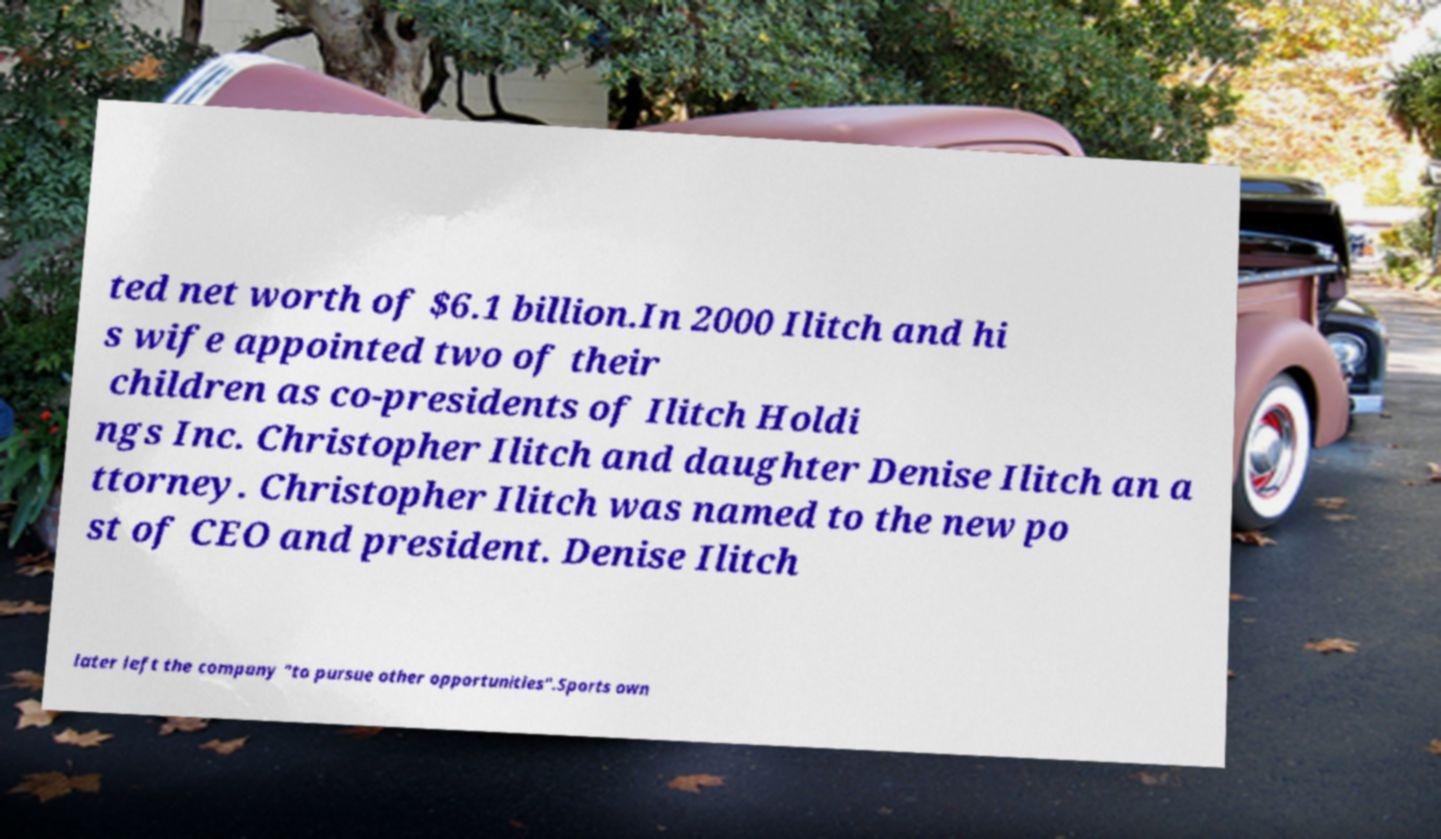Could you extract and type out the text from this image? ted net worth of $6.1 billion.In 2000 Ilitch and hi s wife appointed two of their children as co-presidents of Ilitch Holdi ngs Inc. Christopher Ilitch and daughter Denise Ilitch an a ttorney. Christopher Ilitch was named to the new po st of CEO and president. Denise Ilitch later left the company "to pursue other opportunities".Sports own 